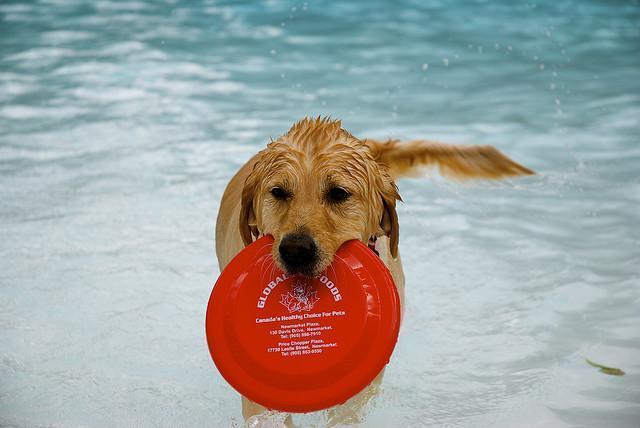How many boats are moving in the photo?
Give a very brief answer. 0. 